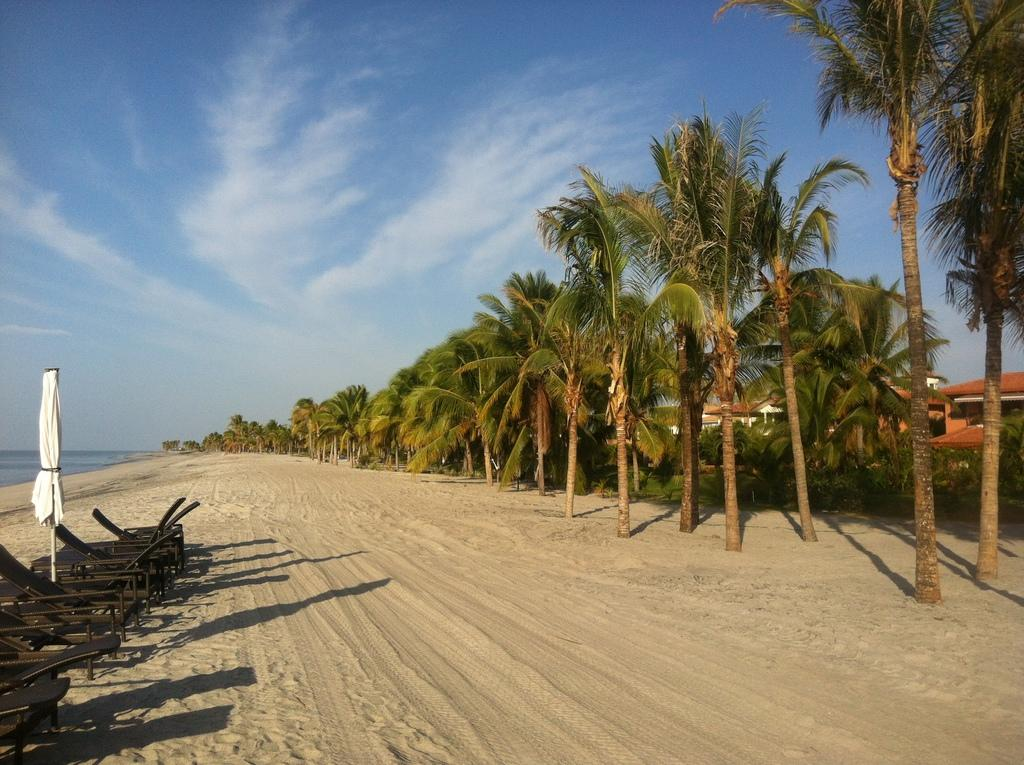What type of terrain is visible in the image? There is sand in the image. What natural elements can be seen in the image? There are trees and plants visible in the image. What type of structures are present in the image? There are houses in the image. What type of seating is available in the image? There are chairs in the image. What natural body can be seen in the image? There is water visible in the image. What part of the natural environment is visible in the image? The sky is visible in the image, and there are clouds present. Can you tell me how many babies are playing basketball in the image? There are no babies or basketballs present in the image. 